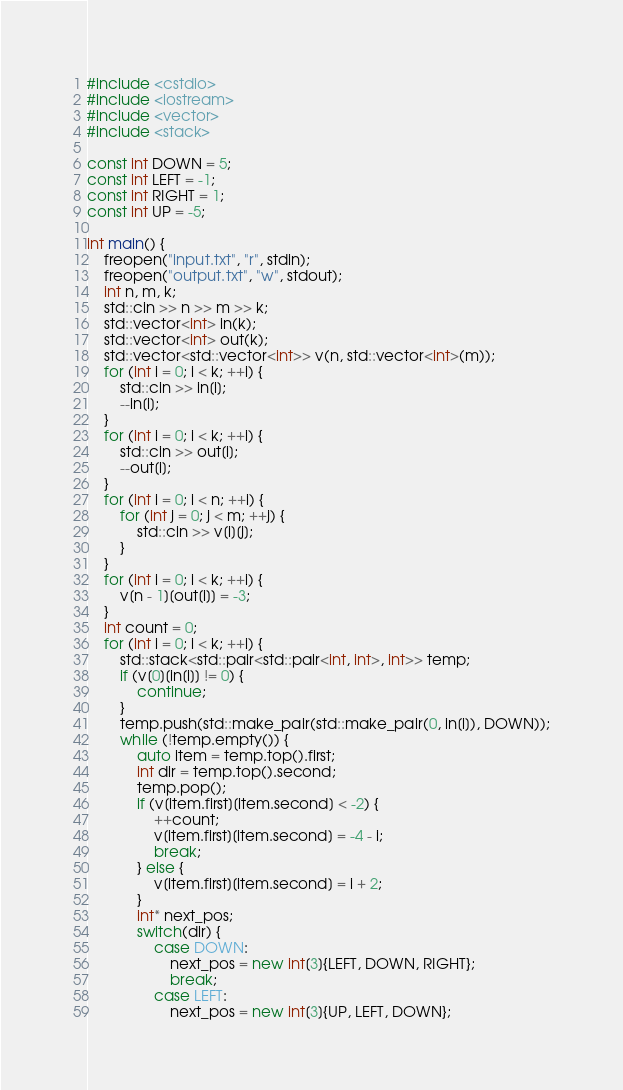<code> <loc_0><loc_0><loc_500><loc_500><_C++_>#include <cstdio>
#include <iostream>
#include <vector>
#include <stack>
 
const int DOWN = 5;
const int LEFT = -1;
const int RIGHT = 1;
const int UP = -5;
 
int main() {
    freopen("input.txt", "r", stdin);
    freopen("output.txt", "w", stdout);
    int n, m, k;
    std::cin >> n >> m >> k;
    std::vector<int> in(k);
    std::vector<int> out(k);
    std::vector<std::vector<int>> v(n, std::vector<int>(m));
    for (int i = 0; i < k; ++i) {
        std::cin >> in[i];
        --in[i];
    }
    for (int i = 0; i < k; ++i) {
        std::cin >> out[i];
        --out[i];
    }
    for (int i = 0; i < n; ++i) {
        for (int j = 0; j < m; ++j) {
            std::cin >> v[i][j];
        }
    }
    for (int i = 0; i < k; ++i) {
        v[n - 1][out[i]] = -3;
    }
    int count = 0;
    for (int i = 0; i < k; ++i) {
        std::stack<std::pair<std::pair<int, int>, int>> temp;
        if (v[0][in[i]] != 0) {
            continue;
        }
        temp.push(std::make_pair(std::make_pair(0, in[i]), DOWN));
        while (!temp.empty()) {
            auto item = temp.top().first;
            int dir = temp.top().second;
            temp.pop();
            if (v[item.first][item.second] < -2) {
                ++count;
                v[item.first][item.second] = -4 - i;
                break;
            } else {
                v[item.first][item.second] = i + 2;
            }
            int* next_pos;
            switch(dir) {
                case DOWN:
                    next_pos = new int[3]{LEFT, DOWN, RIGHT};
                    break;
                case LEFT:
                    next_pos = new int[3]{UP, LEFT, DOWN};</code> 